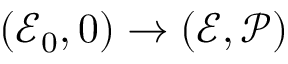<formula> <loc_0><loc_0><loc_500><loc_500>( \ m a t h s c r { E } _ { 0 } , 0 ) \to ( \ m a t h s c r { E } , \ m a t h s c r { P } )</formula> 